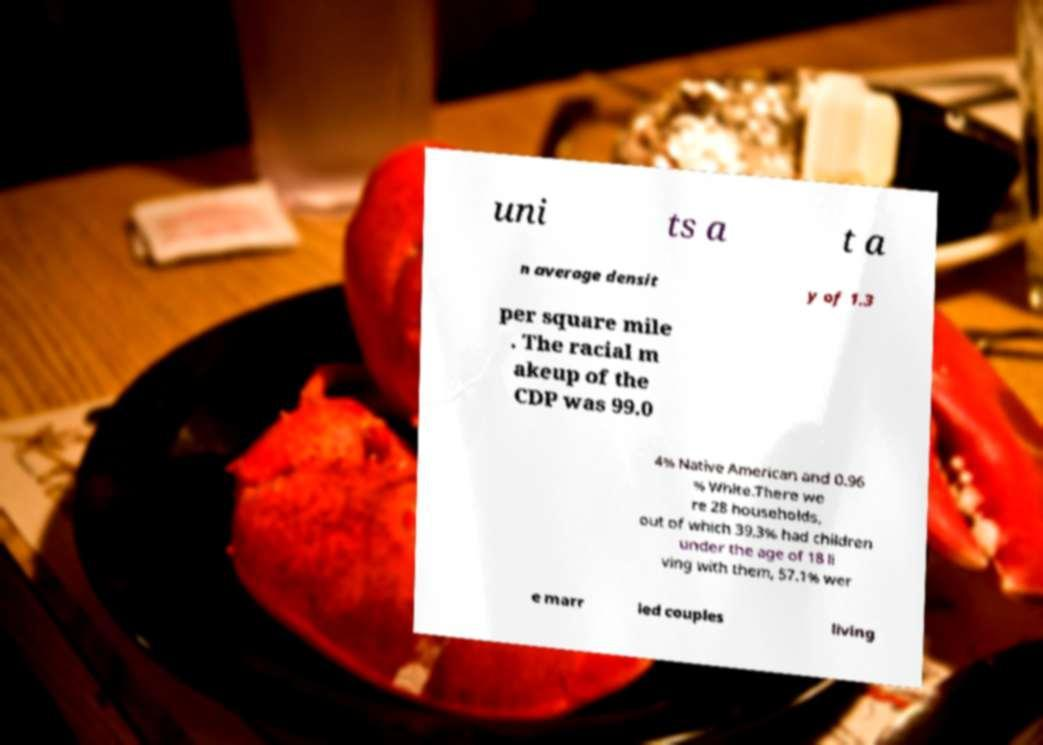For documentation purposes, I need the text within this image transcribed. Could you provide that? uni ts a t a n average densit y of 1.3 per square mile . The racial m akeup of the CDP was 99.0 4% Native American and 0.96 % White.There we re 28 households, out of which 39.3% had children under the age of 18 li ving with them, 57.1% wer e marr ied couples living 